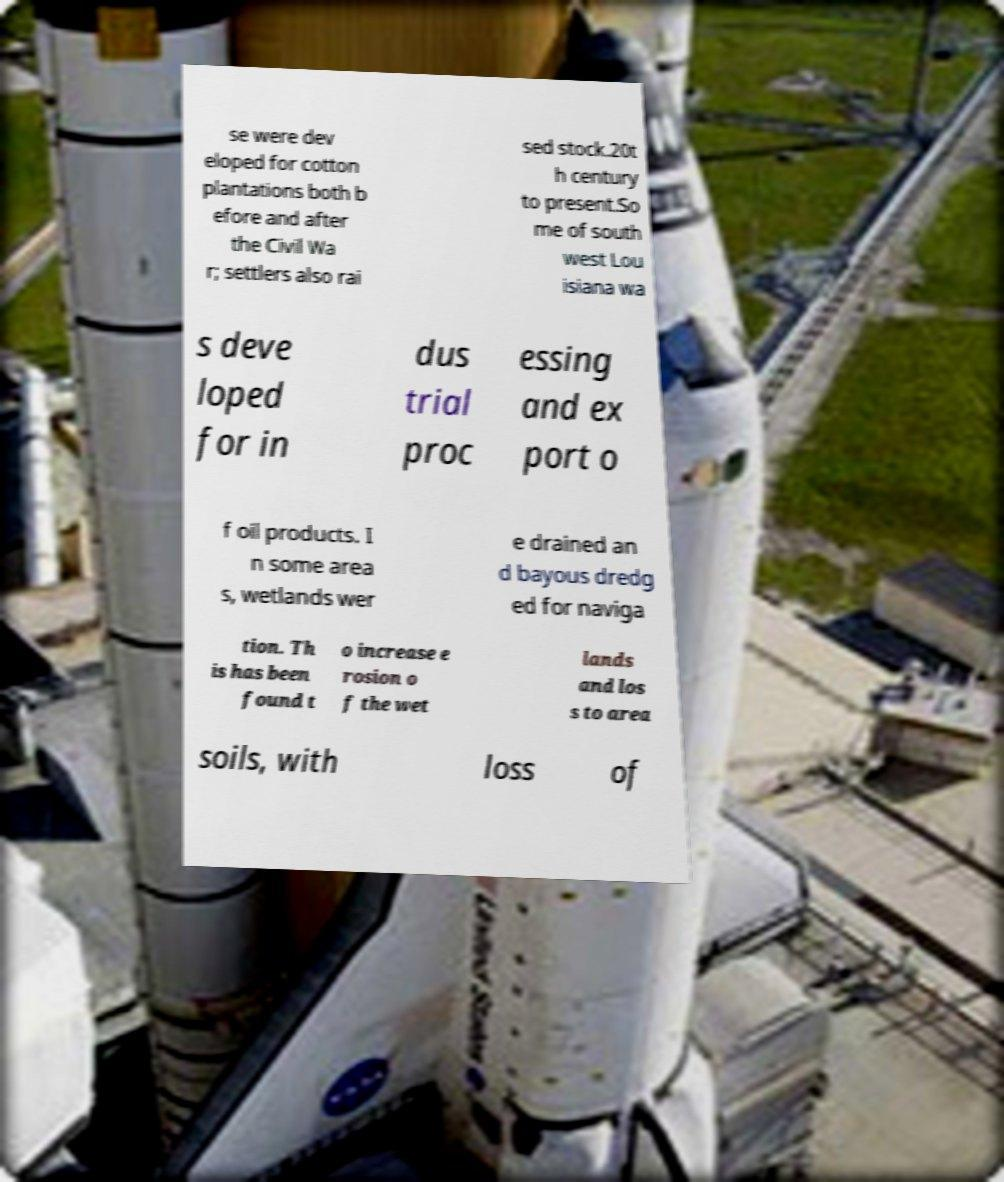For documentation purposes, I need the text within this image transcribed. Could you provide that? se were dev eloped for cotton plantations both b efore and after the Civil Wa r; settlers also rai sed stock.20t h century to present.So me of south west Lou isiana wa s deve loped for in dus trial proc essing and ex port o f oil products. I n some area s, wetlands wer e drained an d bayous dredg ed for naviga tion. Th is has been found t o increase e rosion o f the wet lands and los s to area soils, with loss of 